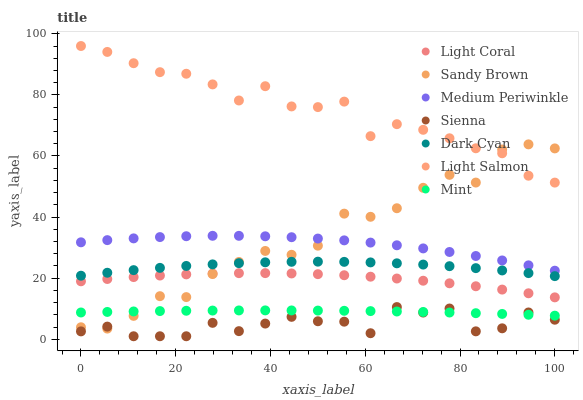Does Sienna have the minimum area under the curve?
Answer yes or no. Yes. Does Light Salmon have the maximum area under the curve?
Answer yes or no. Yes. Does Mint have the minimum area under the curve?
Answer yes or no. No. Does Mint have the maximum area under the curve?
Answer yes or no. No. Is Mint the smoothest?
Answer yes or no. Yes. Is Sandy Brown the roughest?
Answer yes or no. Yes. Is Light Salmon the smoothest?
Answer yes or no. No. Is Light Salmon the roughest?
Answer yes or no. No. Does Sienna have the lowest value?
Answer yes or no. Yes. Does Mint have the lowest value?
Answer yes or no. No. Does Light Salmon have the highest value?
Answer yes or no. Yes. Does Mint have the highest value?
Answer yes or no. No. Is Medium Periwinkle less than Light Salmon?
Answer yes or no. Yes. Is Light Salmon greater than Sienna?
Answer yes or no. Yes. Does Mint intersect Sandy Brown?
Answer yes or no. Yes. Is Mint less than Sandy Brown?
Answer yes or no. No. Is Mint greater than Sandy Brown?
Answer yes or no. No. Does Medium Periwinkle intersect Light Salmon?
Answer yes or no. No. 